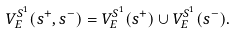Convert formula to latex. <formula><loc_0><loc_0><loc_500><loc_500>V ^ { S ^ { 1 } } _ { E } ( { s } ^ { + } , { s } ^ { - } ) = V _ { E } ^ { S ^ { 1 } } ( s ^ { + } ) \cup V _ { E } ^ { S ^ { 1 } } ( s ^ { - } ) .</formula> 